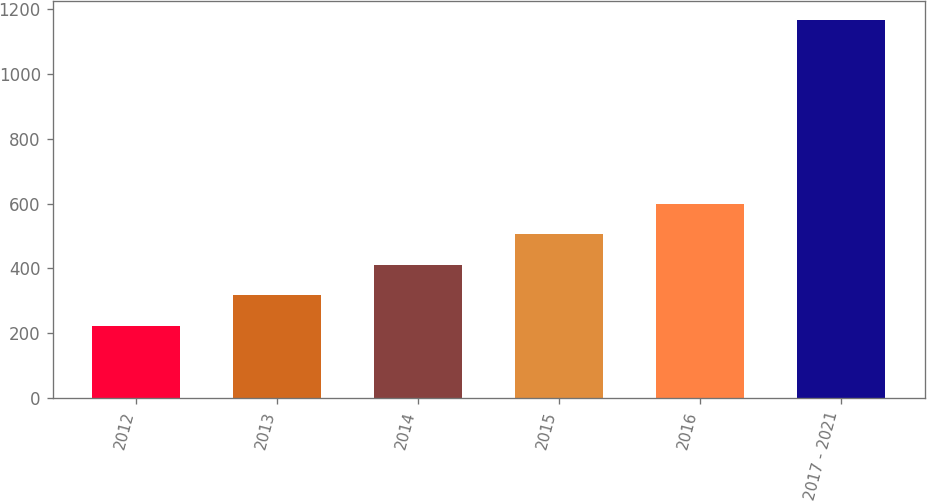<chart> <loc_0><loc_0><loc_500><loc_500><bar_chart><fcel>2012<fcel>2013<fcel>2014<fcel>2015<fcel>2016<fcel>2017 - 2021<nl><fcel>223<fcel>317.4<fcel>411.8<fcel>506.2<fcel>600.6<fcel>1167<nl></chart> 